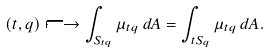Convert formula to latex. <formula><loc_0><loc_0><loc_500><loc_500>( t , q ) \longmapsto \int _ { S _ { t q } } \mu _ { t q } \, d A = \int _ { t S _ { q } } \mu _ { t q } \, d A .</formula> 